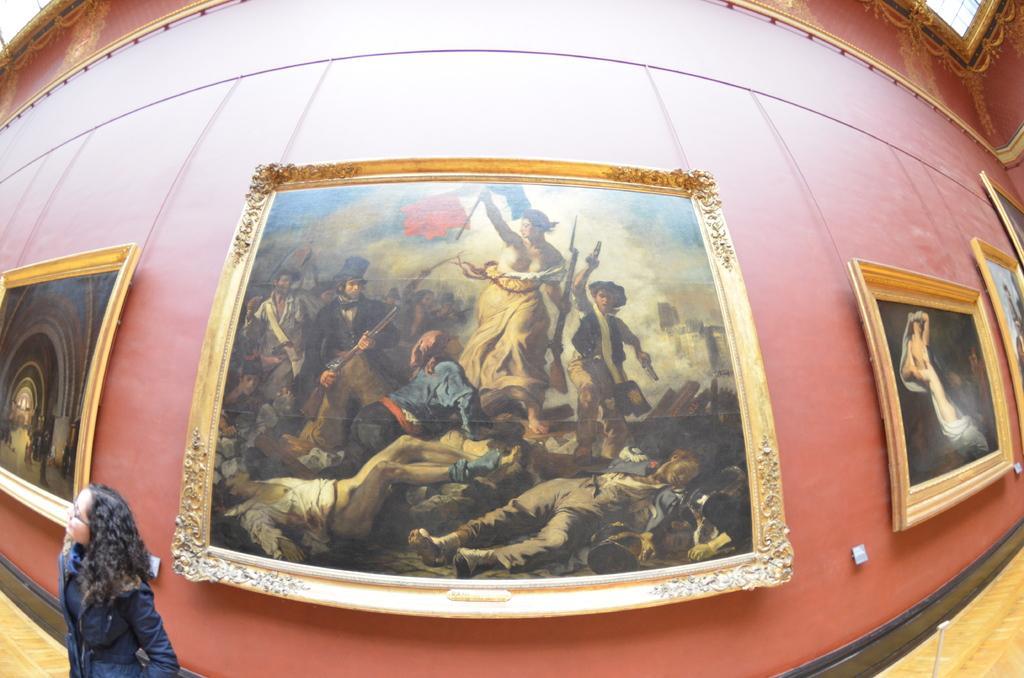How would you summarize this image in a sentence or two? In this image I can see few frames attached to the wall. I can see the inner part of the building and the person. 